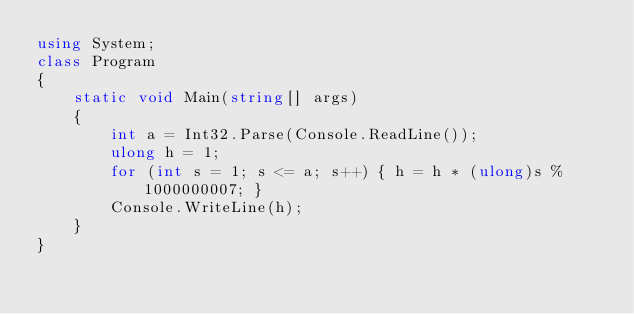Convert code to text. <code><loc_0><loc_0><loc_500><loc_500><_C#_>using System;
class Program
{
    static void Main(string[] args)
    {
        int a = Int32.Parse(Console.ReadLine());
        ulong h = 1;
        for (int s = 1; s <= a; s++) { h = h * (ulong)s % 1000000007; }
        Console.WriteLine(h);
    }
}
</code> 